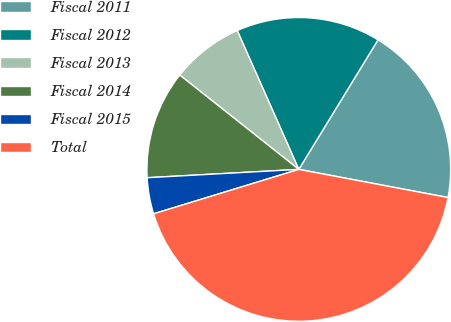<chart> <loc_0><loc_0><loc_500><loc_500><pie_chart><fcel>Fiscal 2011<fcel>Fiscal 2012<fcel>Fiscal 2013<fcel>Fiscal 2014<fcel>Fiscal 2015<fcel>Total<nl><fcel>19.23%<fcel>15.38%<fcel>7.69%<fcel>11.54%<fcel>3.85%<fcel>42.31%<nl></chart> 